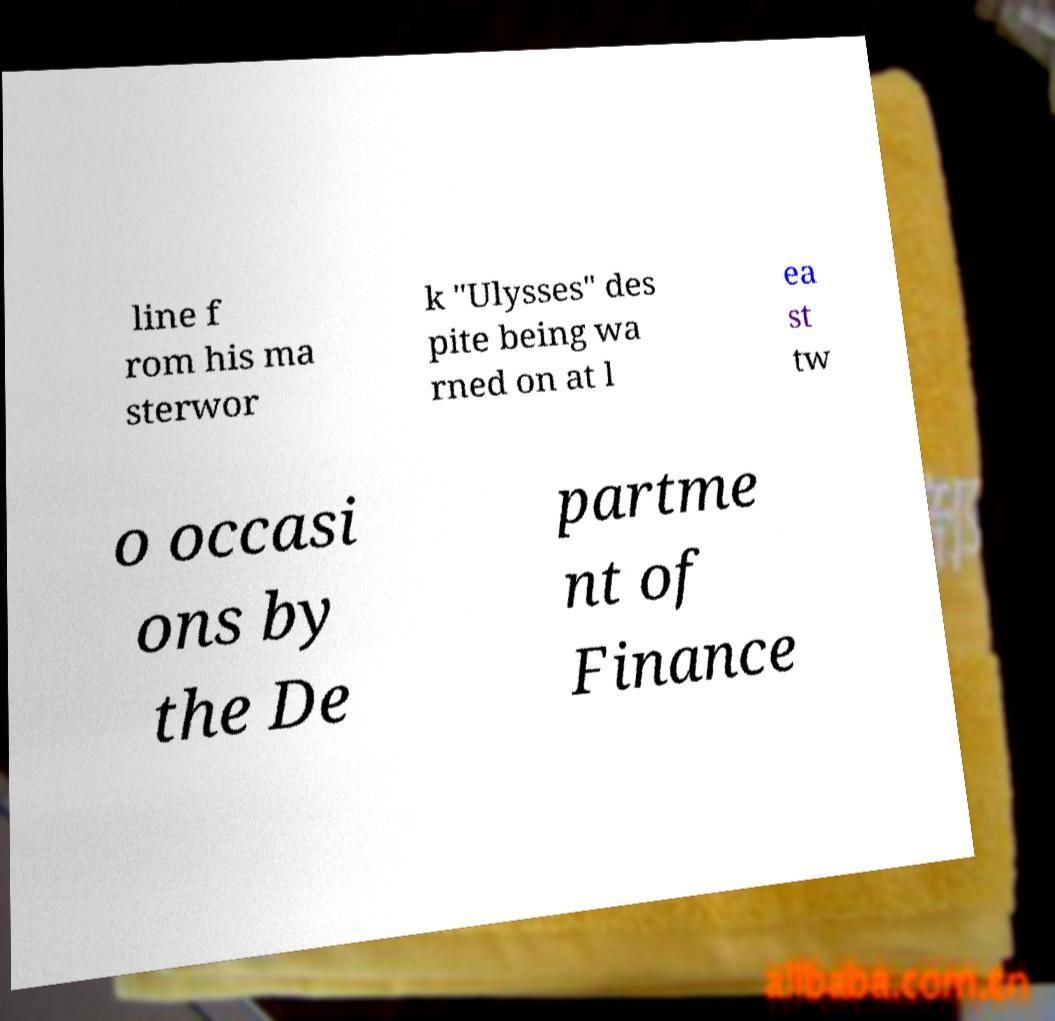Could you assist in decoding the text presented in this image and type it out clearly? line f rom his ma sterwor k "Ulysses" des pite being wa rned on at l ea st tw o occasi ons by the De partme nt of Finance 